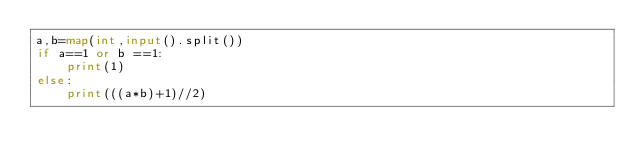<code> <loc_0><loc_0><loc_500><loc_500><_Python_>a,b=map(int,input().split())
if a==1 or b ==1:
    print(1)
else:
    print(((a*b)+1)//2)</code> 